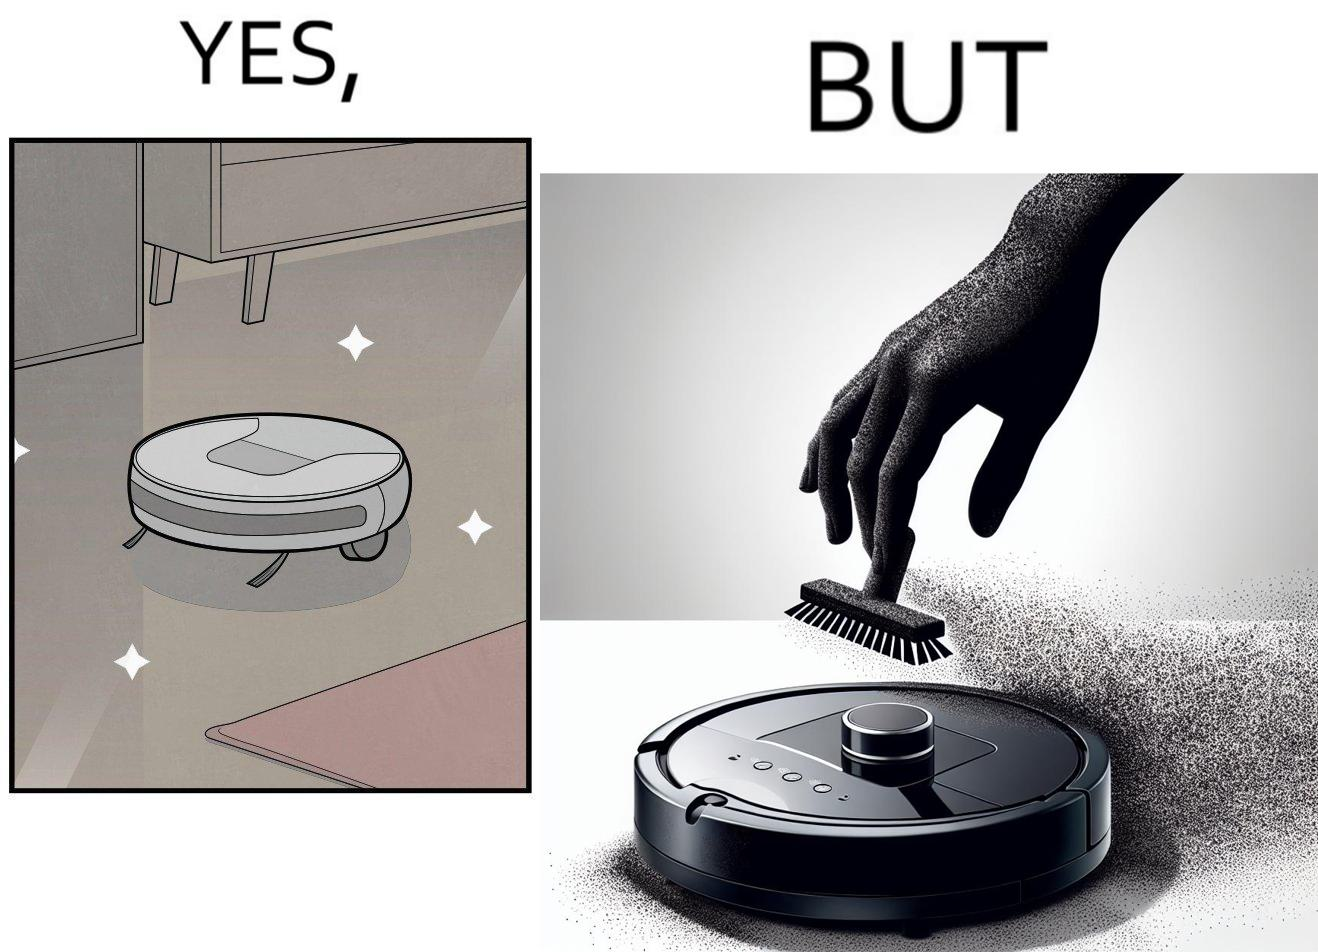Compare the left and right sides of this image. In the left part of the image: A vacuum cleaning machine that goes around the floor on its own and cleans the floor. Everything  around it looks squeaky clean, and is shining. In the right part of the image: Close up of a vacuum cleaning machine that goes around the floor on its own and cleans the floor. Everything  around it looks squeaky clean, and is shining, but it has a lot of dust on it except one line on it that looks clean. A persons fingertip is visible, and it is covered in dust. 